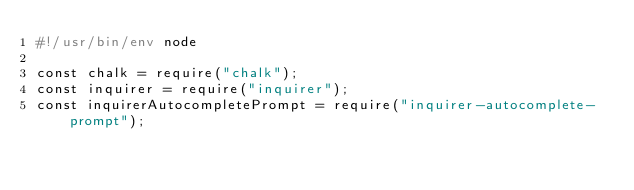<code> <loc_0><loc_0><loc_500><loc_500><_JavaScript_>#!/usr/bin/env node

const chalk = require("chalk");
const inquirer = require("inquirer");
const inquirerAutocompletePrompt = require("inquirer-autocomplete-prompt");</code> 